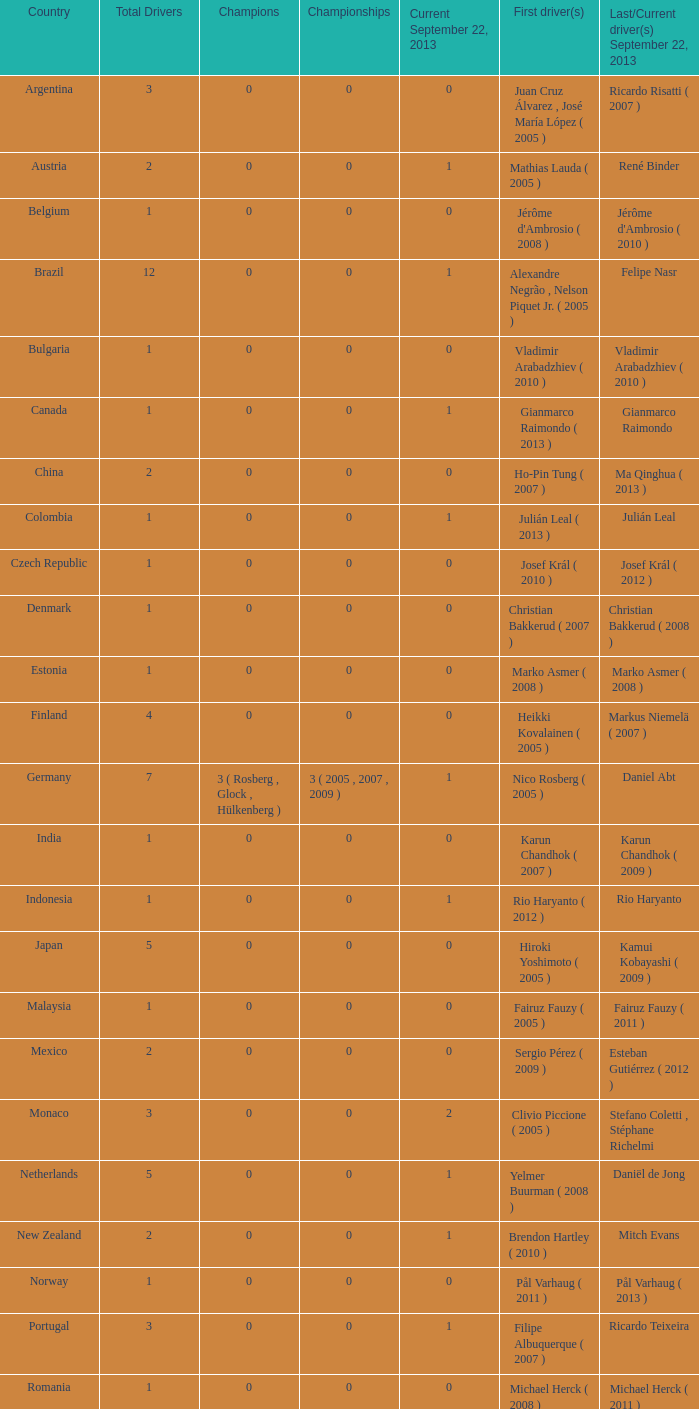How many champions had there been by the time gianmarco raimondo was the latest one? 0.0. 